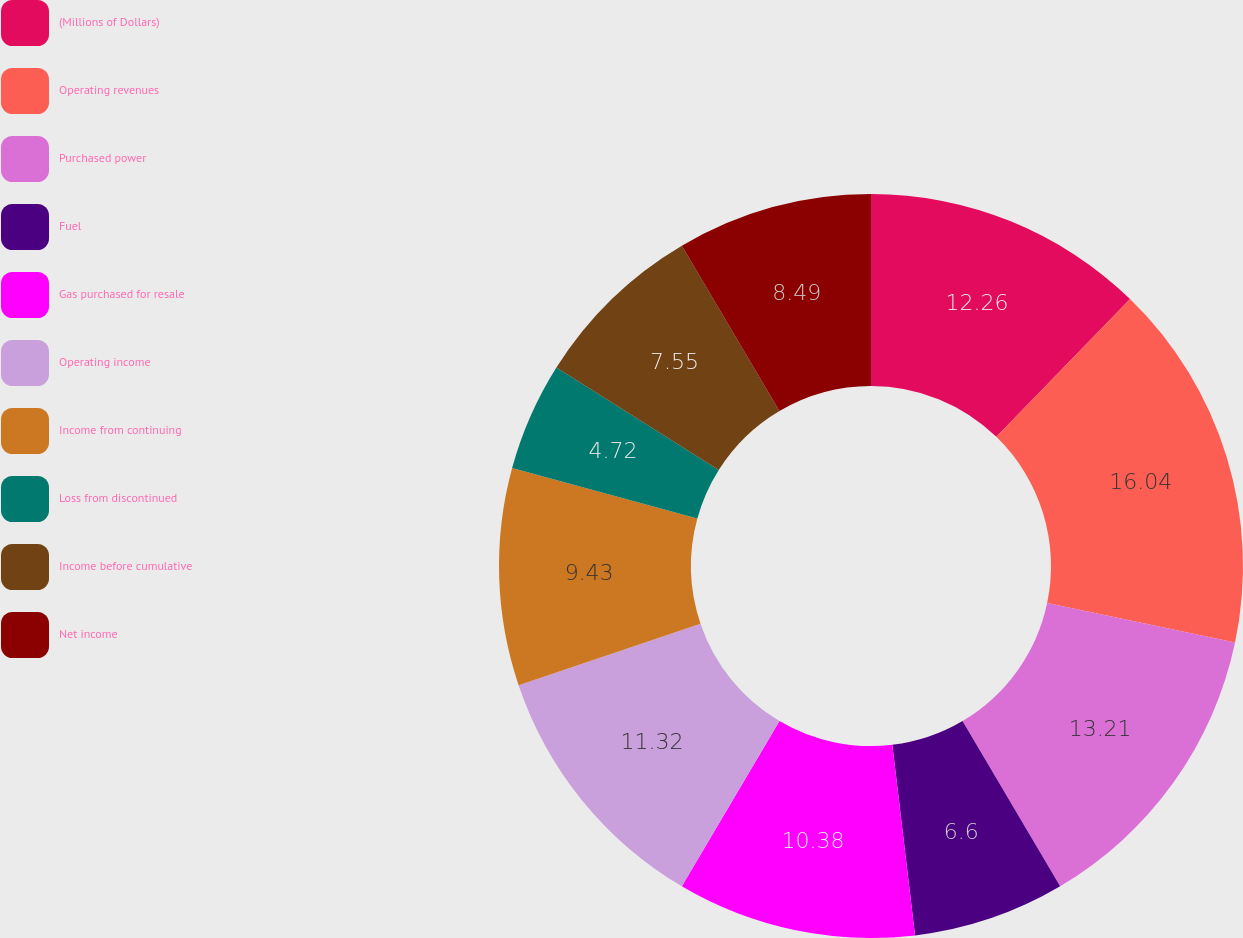<chart> <loc_0><loc_0><loc_500><loc_500><pie_chart><fcel>(Millions of Dollars)<fcel>Operating revenues<fcel>Purchased power<fcel>Fuel<fcel>Gas purchased for resale<fcel>Operating income<fcel>Income from continuing<fcel>Loss from discontinued<fcel>Income before cumulative<fcel>Net income<nl><fcel>12.26%<fcel>16.04%<fcel>13.21%<fcel>6.6%<fcel>10.38%<fcel>11.32%<fcel>9.43%<fcel>4.72%<fcel>7.55%<fcel>8.49%<nl></chart> 